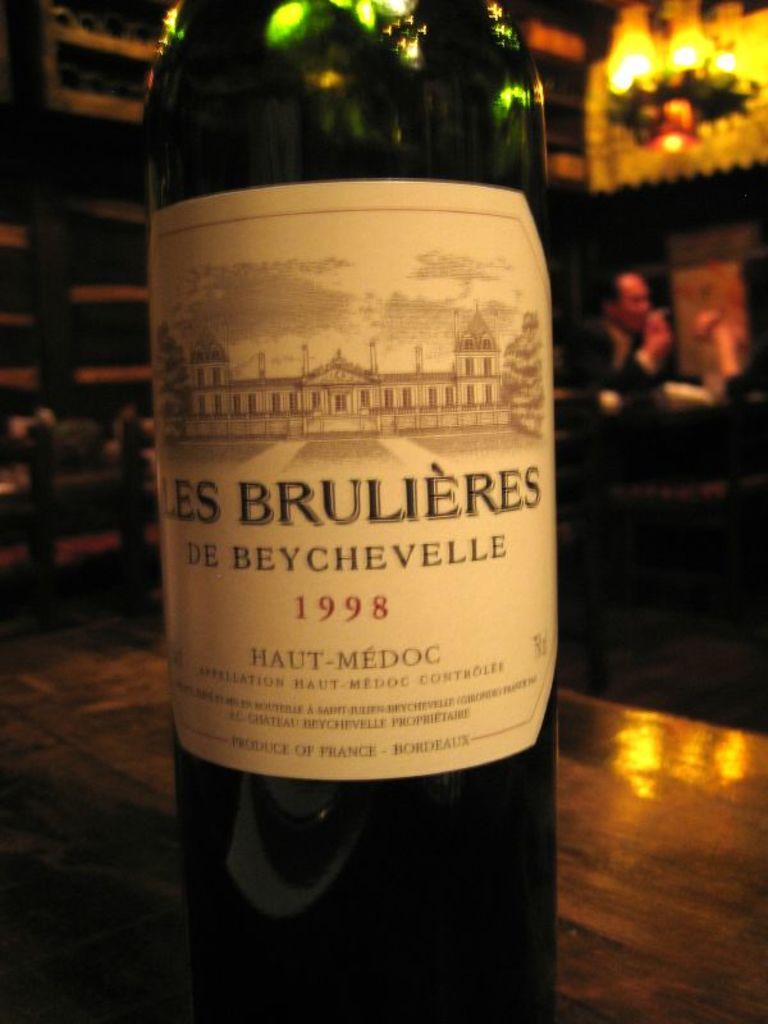What is the year of the wine?
Your response must be concise. 1998. What country was it made it?
Offer a very short reply. France. 